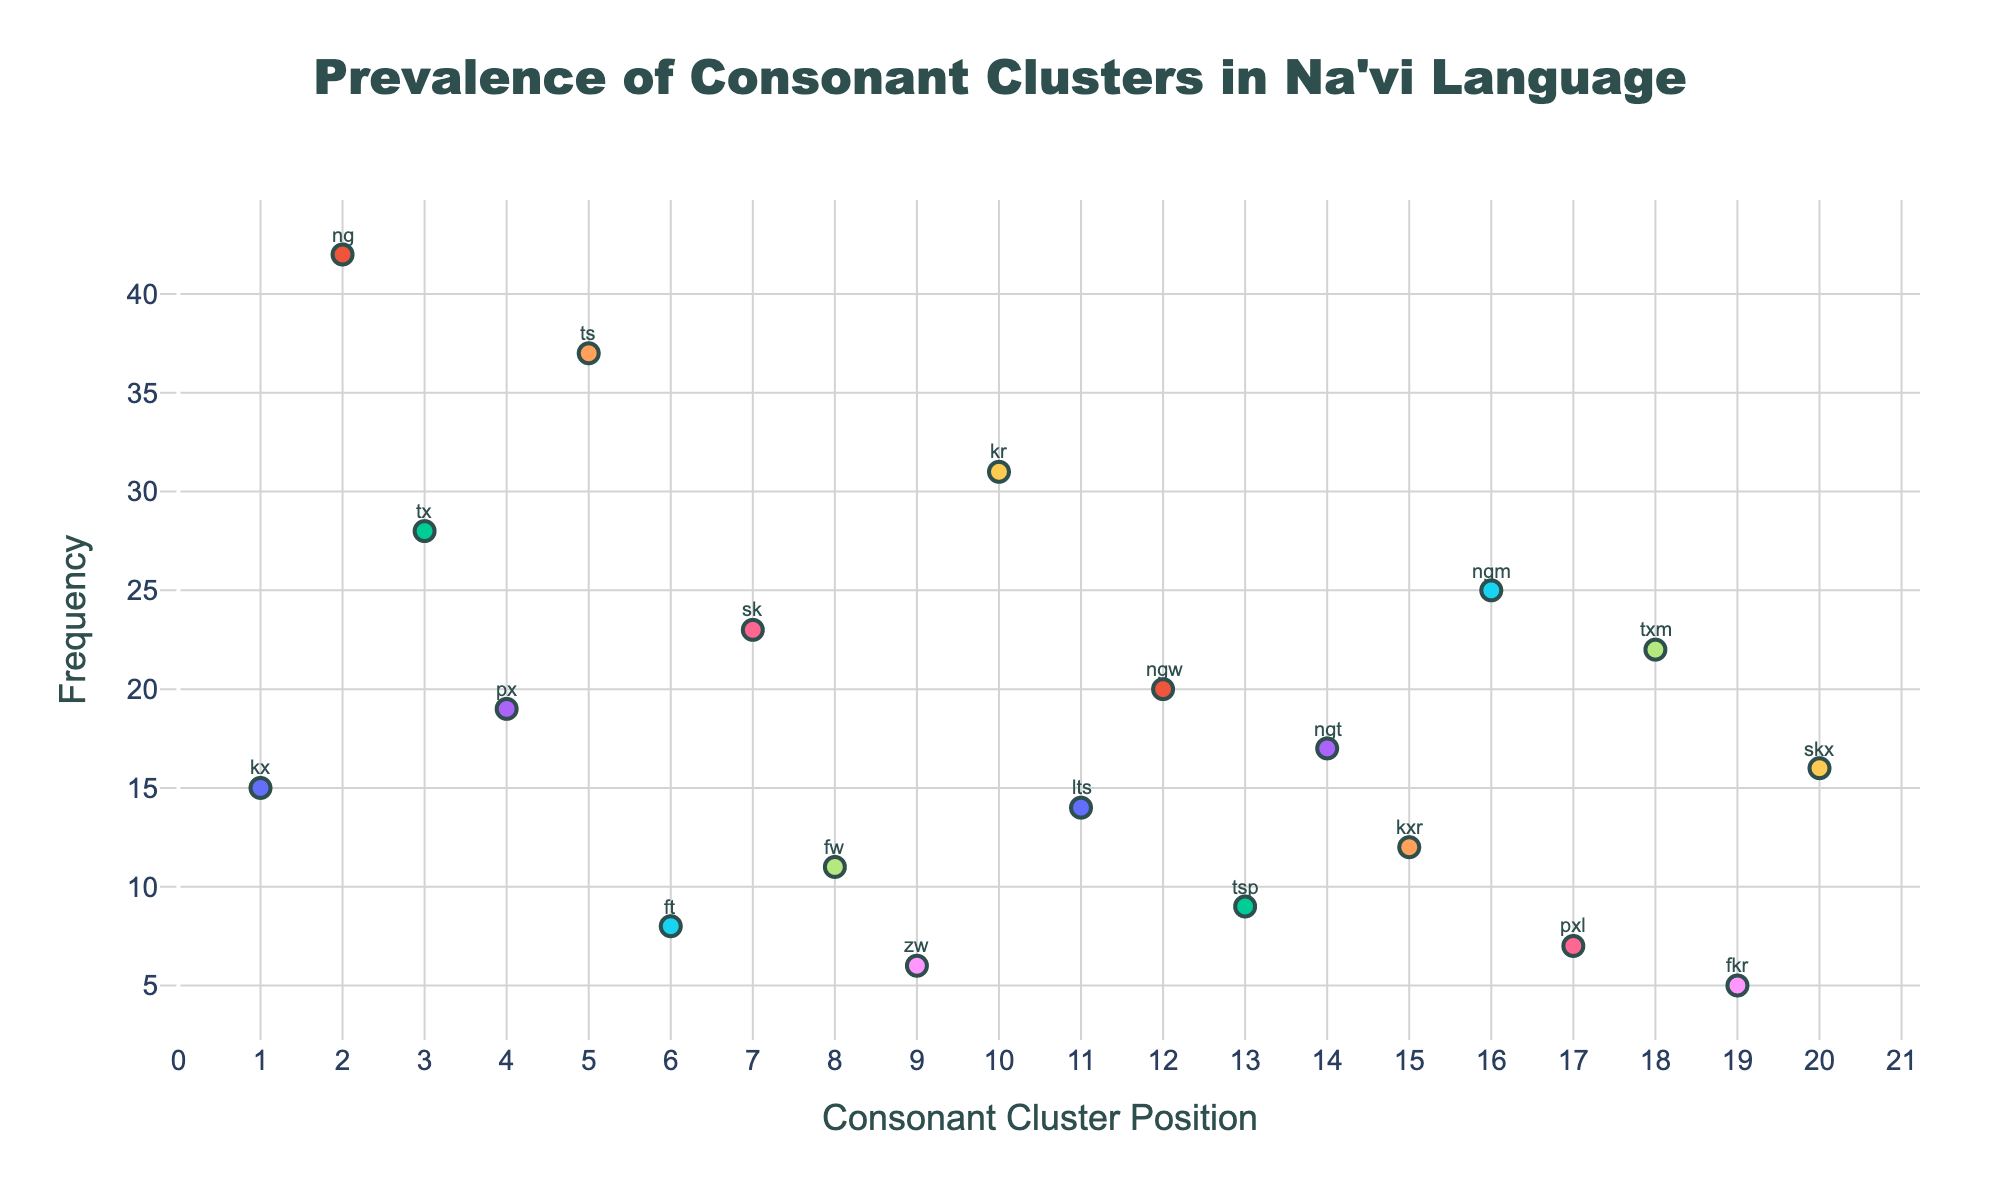What is the title of the figure? The title is displayed prominently at the top of the figure.
Answer: Prevalence of Consonant Clusters in Na'vi Language How many consonant clusters are represented in the plot? Count the data points (markers) in the plot; each represents a different consonant cluster.
Answer: 20 Which consonant cluster has the highest frequency? Identify the data point at the highest position on the y-axis.
Answer: ng What is the frequency of the consonant cluster "ts"? Locate the marker for "ts" and refer to its position on the y-axis.
Answer: 37 What are the x- and y-axis titles of the plot? Look at the labels on the horizontal and vertical axes.
Answer: Consonant Cluster Position and Frequency Which consonant cluster has a frequency of 5? Find the marker that aligns with the frequency value of 5 on the y-axis.
Answer: fkr Which consonant cluster comes immediately after "tx" in terms of position? Identify the position values from the x-axis and see which cluster follows the one marked "tx".
Answer: px Which consonant cluster has a lower frequency, "px" or "fw"? Compare the positions of "px" and "fw" on the y-axis.
Answer: fw Is the frequency of "ngm" greater than or equal to 25? Locate "ngm" on the y-axis and check if its frequency is 25 or more.
Answer: Yes 